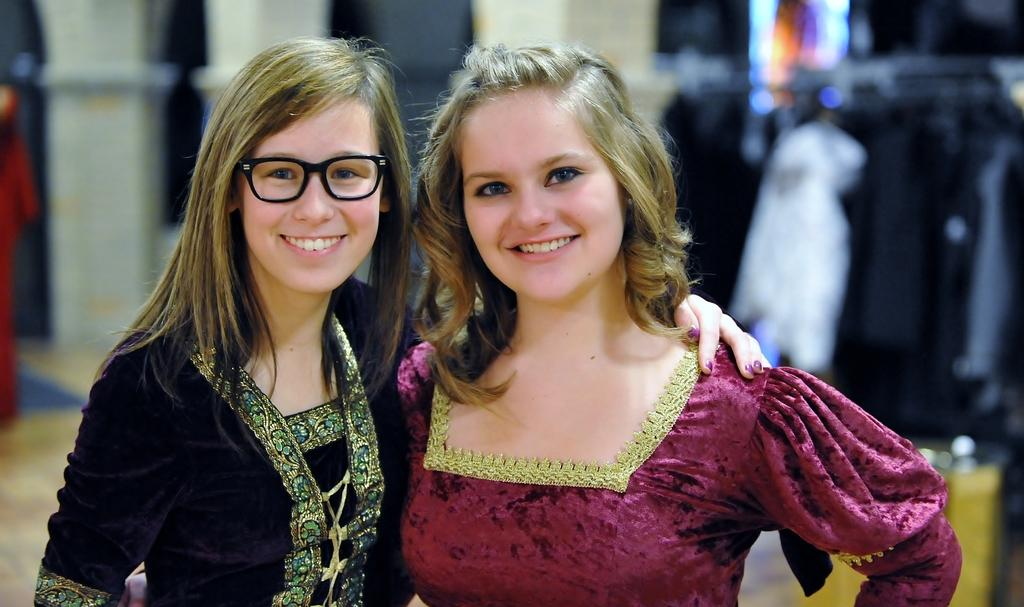How many girls are present in the image? There are two girls in the image. What expressions do the girls have? Both girls are smiling. What colors and patterns can be seen on the girls' dresses? One girl is wearing a pink dress, and the other girl is wearing a black dress with specks. What type of soap is being used by the girls in the image? There is no soap present in the image; the girls are not engaged in any activity that would involve using soap. 